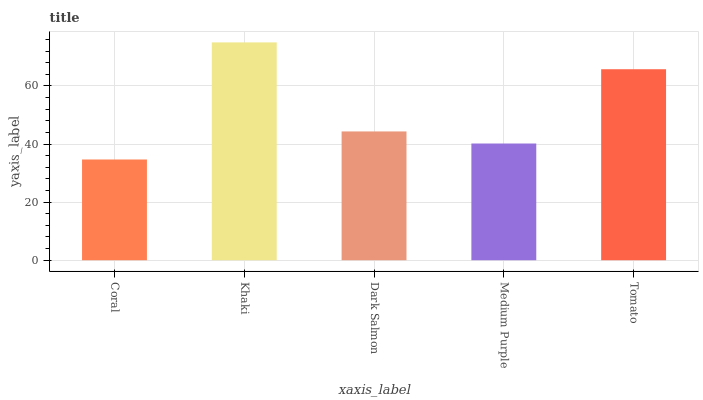Is Coral the minimum?
Answer yes or no. Yes. Is Khaki the maximum?
Answer yes or no. Yes. Is Dark Salmon the minimum?
Answer yes or no. No. Is Dark Salmon the maximum?
Answer yes or no. No. Is Khaki greater than Dark Salmon?
Answer yes or no. Yes. Is Dark Salmon less than Khaki?
Answer yes or no. Yes. Is Dark Salmon greater than Khaki?
Answer yes or no. No. Is Khaki less than Dark Salmon?
Answer yes or no. No. Is Dark Salmon the high median?
Answer yes or no. Yes. Is Dark Salmon the low median?
Answer yes or no. Yes. Is Khaki the high median?
Answer yes or no. No. Is Tomato the low median?
Answer yes or no. No. 